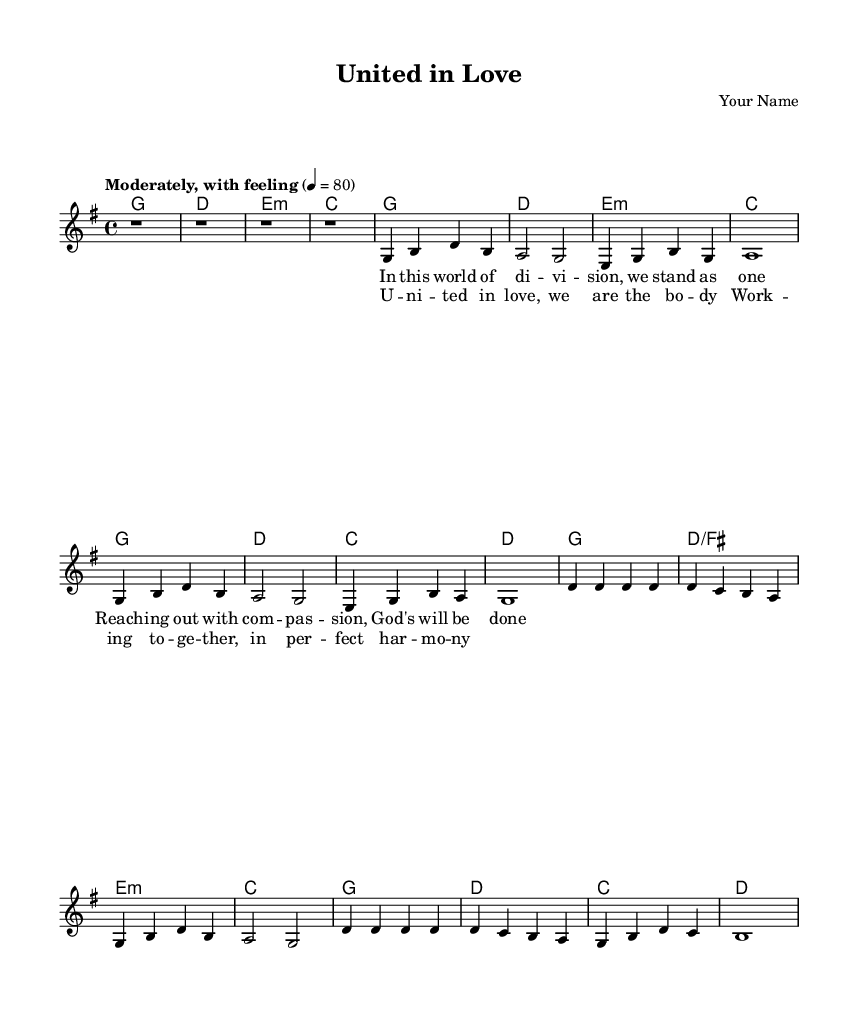What is the key signature of this music? The key signature is G major, which has one sharp (F#). This is indicated at the beginning of the music sheet.
Answer: G major What is the time signature of this piece? The time signature is 4/4, which means there are four beats in each measure, and the quarter note gets one beat. This is clearly marked at the beginning of the sheet music.
Answer: 4/4 What is the tempo marking of this piece? The tempo marking is "Moderately, with feeling," which suggests a moderate pace of approximately 80 beats per minute. This is specified in the score.
Answer: Moderately, with feeling How many measures are in the chorus? The chorus consists of four measures, which can be verified by counting the measure bars in the section labeled as "Chorus."
Answer: Four What is the first chord of the verse? The first chord of the verse is G major, as indicated in the chord notation at the beginning of the verse section.
Answer: G major What theme is presented in the lyrics of this song? The lyrics emphasize community and collaboration among believers, highlighting unity and working together. This can be inferred from both the verse and chorus lyrics that talk about standing as one and being united in love.
Answer: Community and collaboration What is the last chord in the chorus? The last chord in the chorus is D major, seen at the end of the chord progression for that section.
Answer: D major 